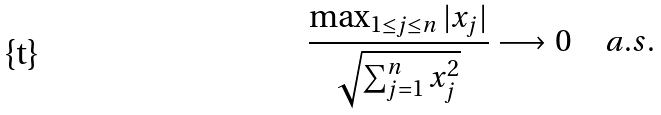<formula> <loc_0><loc_0><loc_500><loc_500>\frac { \max _ { 1 \leq j \leq n } | x _ { j } | } { \sqrt { \sum _ { j = 1 } ^ { n } x _ { j } ^ { 2 } } } \longrightarrow 0 \quad a . s .</formula> 